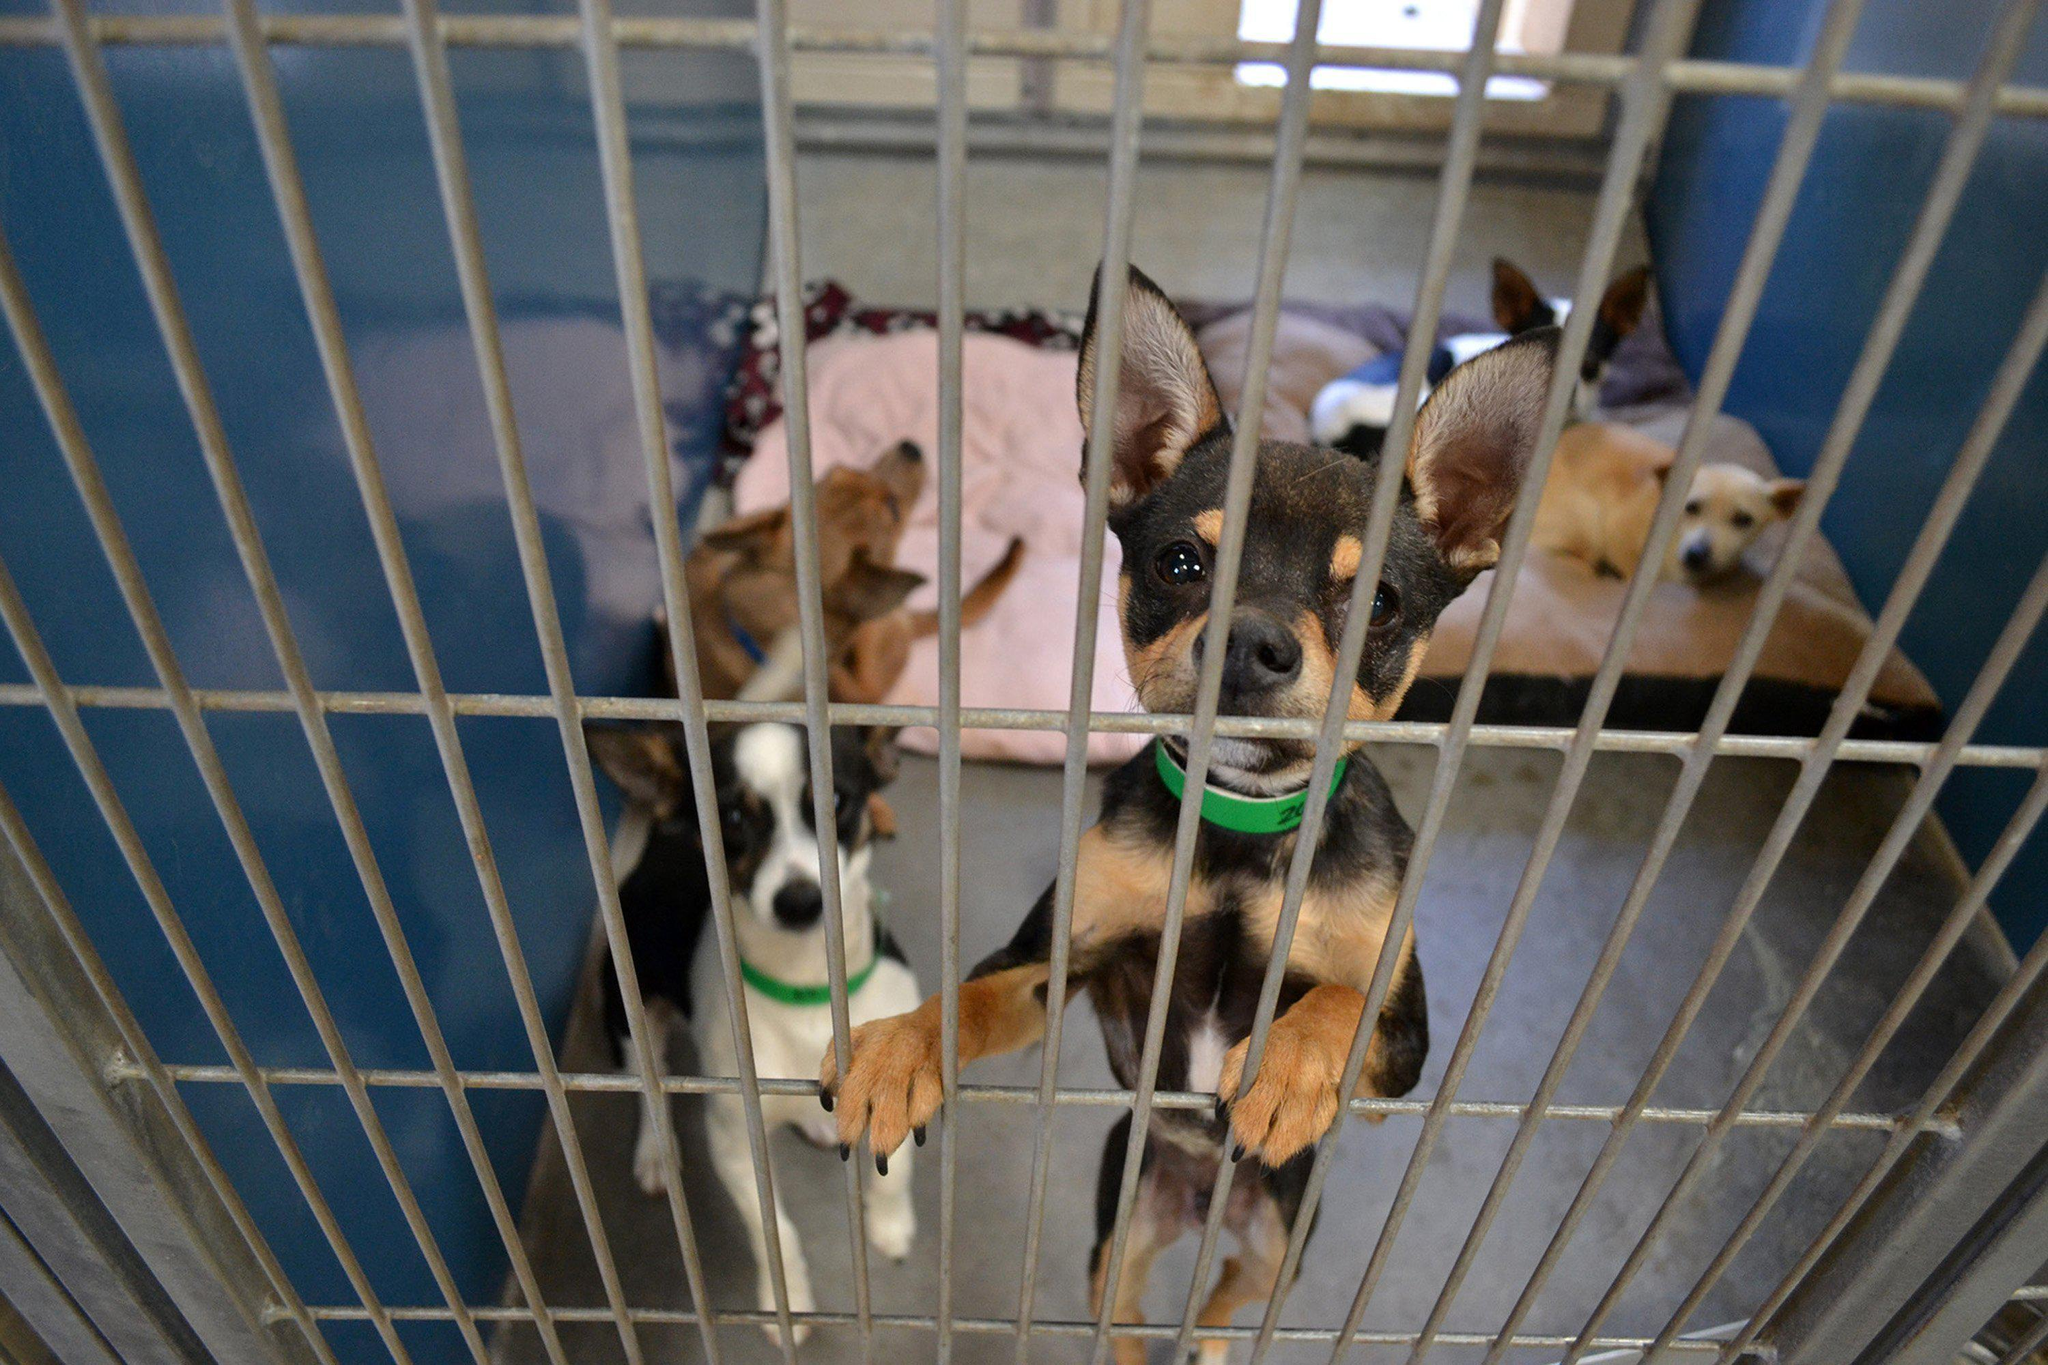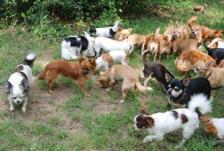The first image is the image on the left, the second image is the image on the right. Given the left and right images, does the statement "An image shows one dog, which is in a grassy area." hold true? Answer yes or no. No. The first image is the image on the left, the second image is the image on the right. For the images displayed, is the sentence "There is no more than one chihuahua in the right image." factually correct? Answer yes or no. No. 